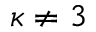<formula> <loc_0><loc_0><loc_500><loc_500>\kappa \neq 3</formula> 